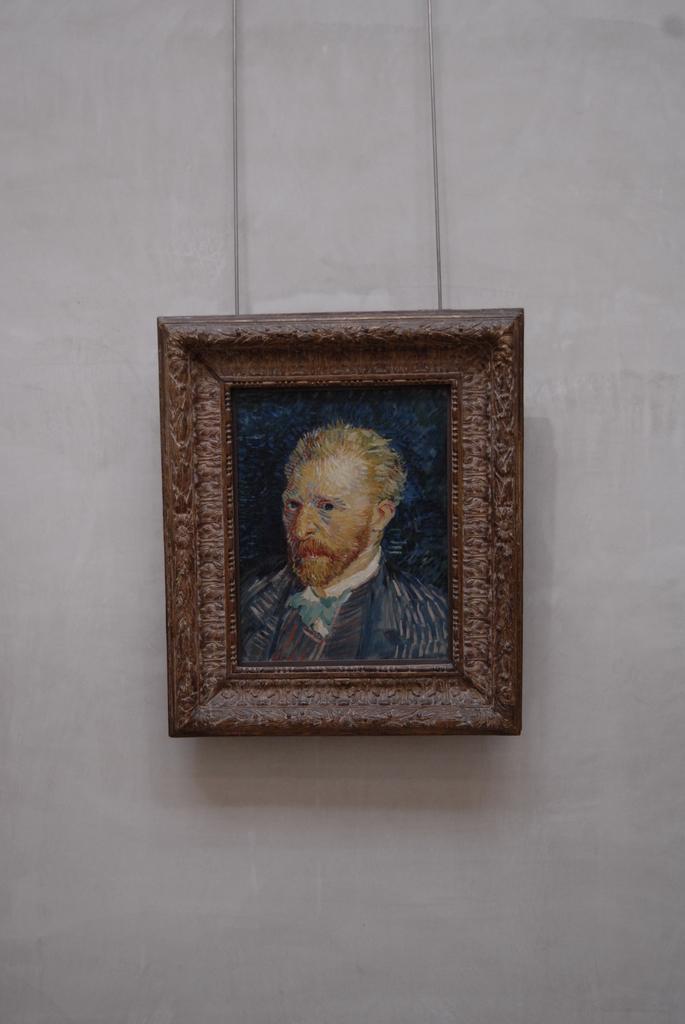How would you summarize this image in a sentence or two? In this image we can see a photo frame on a wall. On the photo frame there is a painting of a person. 